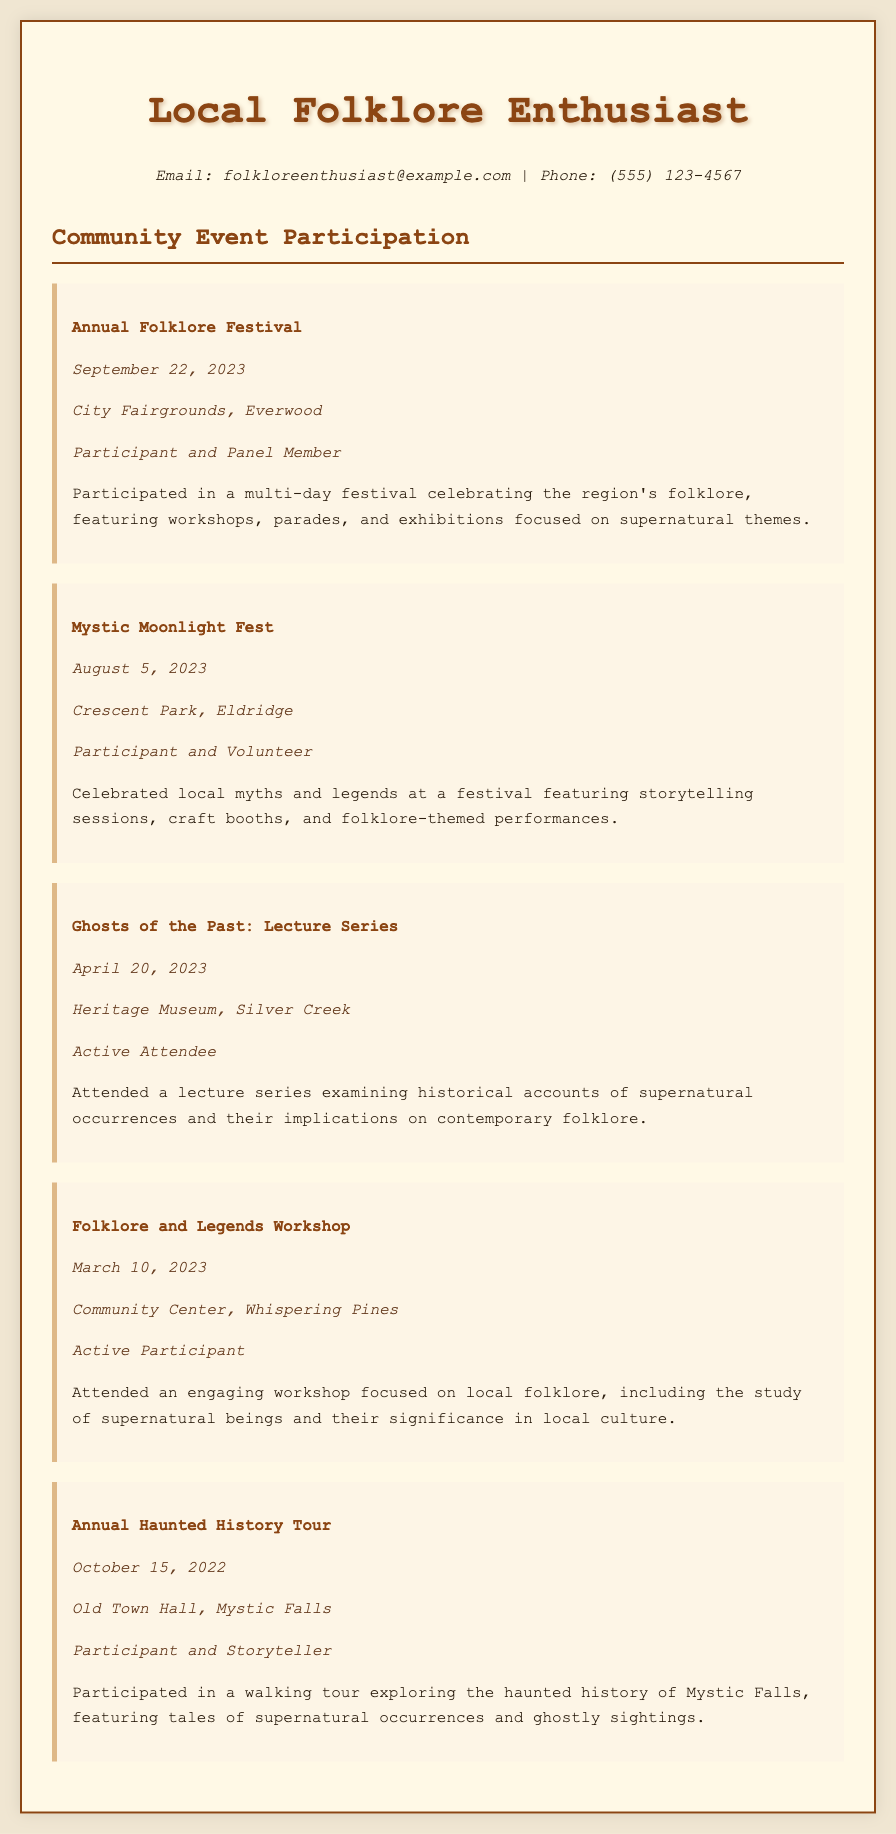What is the title of the first event listed? The title of the first event listed is found in the document section that details the Annual Folklore Festival.
Answer: Annual Folklore Festival When did the Mystic Moonlight Fest occur? The date of the Mystic Moonlight Fest can be found in the event description of that particular event listing.
Answer: August 5, 2023 Where was the Ghosts of the Past: Lecture Series held? The location of this event is mentioned in the event description under Ghosts of the Past: Lecture Series.
Answer: Heritage Museum, Silver Creek What role did the participant play at the Annual Haunted History Tour? The participant's role is specified in the event details for the Annual Haunted History Tour.
Answer: Participant and Storyteller How many events focused on supernatural themes were held in 2023? The events in 2023 with supernatural themes can be counted from the document occurrences throughout that year.
Answer: 3 What kind of events does the document primarily feature? The document showcases events related to local culture, folklore, and supernatural occurrences.
Answer: Folklore festivals Which event includes storytelling sessions? The event that features storytelling sessions is clearly indicated in its description.
Answer: Mystic Moonlight Fest What was the purpose of the Folklore and Legends Workshop? The purpose is explained in the event description of the Folklore and Legends Workshop.
Answer: Study of supernatural beings How would you categorize the document? The document types can be identified as it features community event participation related to a specific interest.
Answer: Curriculum Vitae 